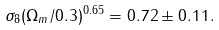<formula> <loc_0><loc_0><loc_500><loc_500>\sigma _ { 8 } ( \Omega _ { m } / 0 . 3 ) ^ { 0 . 6 5 } = 0 . 7 2 \pm 0 . 1 1 .</formula> 